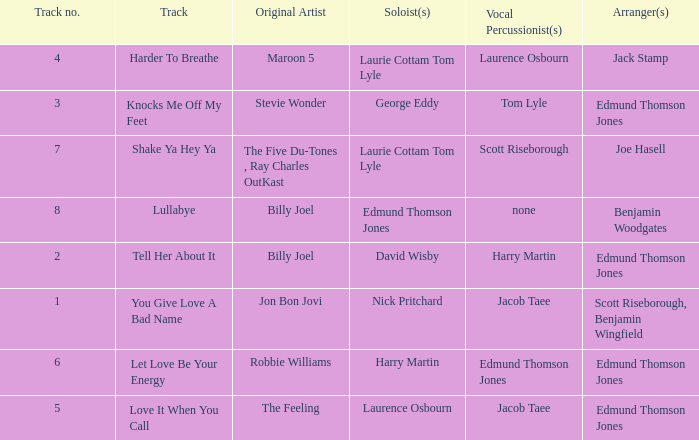Who arranged song(s) with tom lyle on the vocal percussion? Edmund Thomson Jones. 